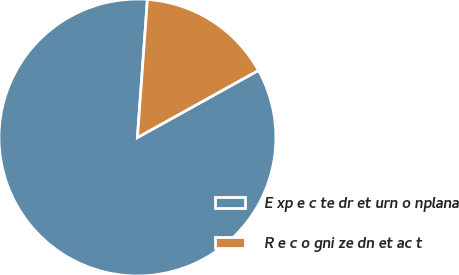Convert chart. <chart><loc_0><loc_0><loc_500><loc_500><pie_chart><fcel>E xp e c te dr et urn o nplana<fcel>R e c o gni ze dn et ac t<nl><fcel>84.21%<fcel>15.79%<nl></chart> 